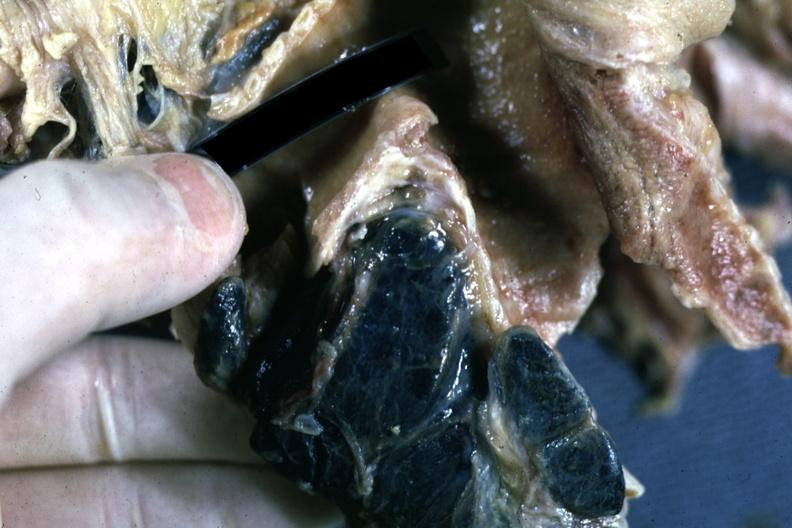what is present?
Answer the question using a single word or phrase. Anthracotic pigment 